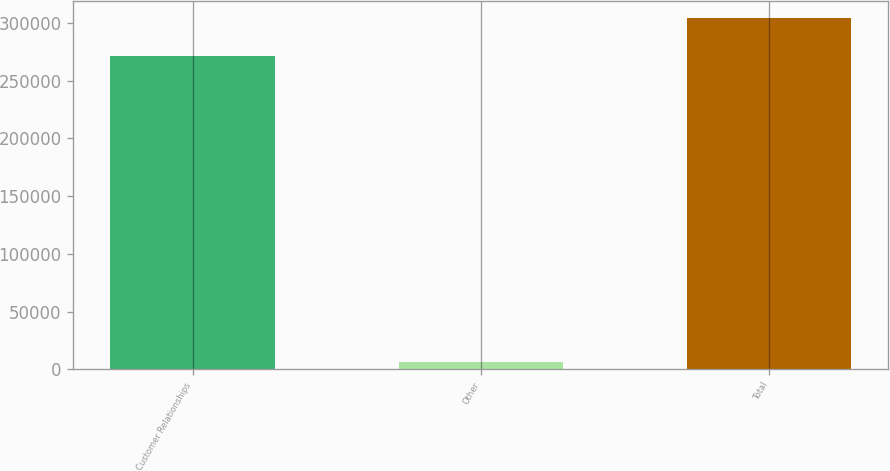Convert chart to OTSL. <chart><loc_0><loc_0><loc_500><loc_500><bar_chart><fcel>Customer Relationships<fcel>Other<fcel>Total<nl><fcel>271123<fcel>6084<fcel>304192<nl></chart> 